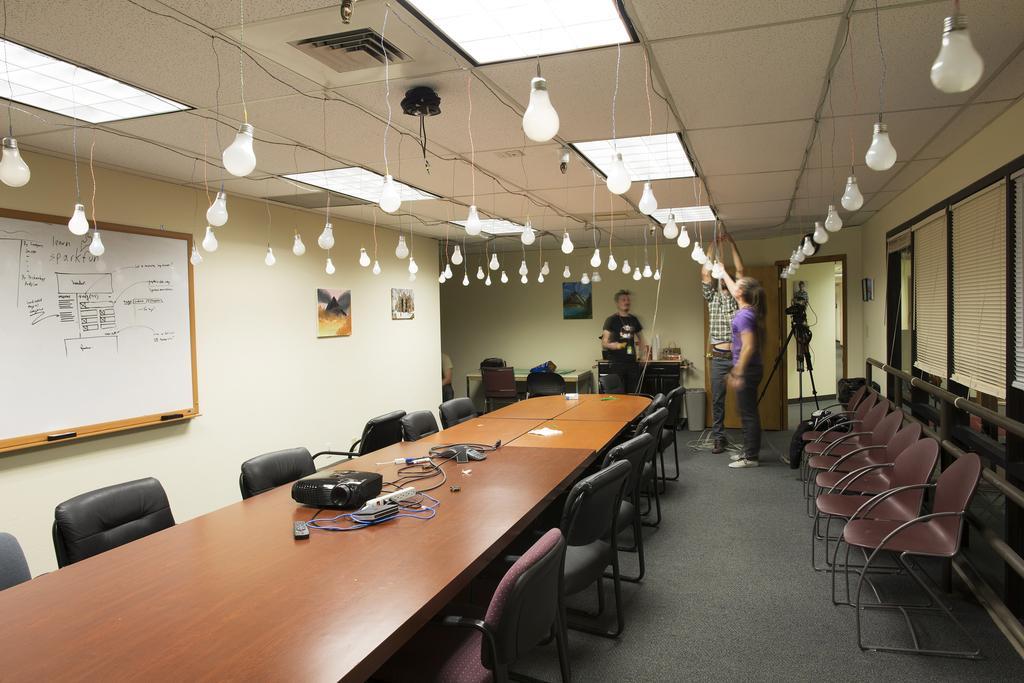Could you give a brief overview of what you see in this image? At the top we can see ceiling, light bulbs and lights. This is a floor. Here we can see chairs and tables and on the table we can see remote, projector device and papers. Here we can see three persons standing on the floor. This is a stand with a camera. This is a wall and there are photo frames and a white board on it 